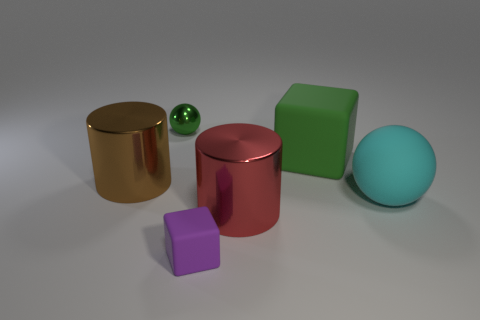Add 4 large red cylinders. How many objects exist? 10 Subtract all cubes. How many objects are left? 4 Add 4 purple rubber blocks. How many purple rubber blocks exist? 5 Subtract 0 gray blocks. How many objects are left? 6 Subtract all large green rubber objects. Subtract all big blue shiny objects. How many objects are left? 5 Add 3 tiny green metallic balls. How many tiny green metallic balls are left? 4 